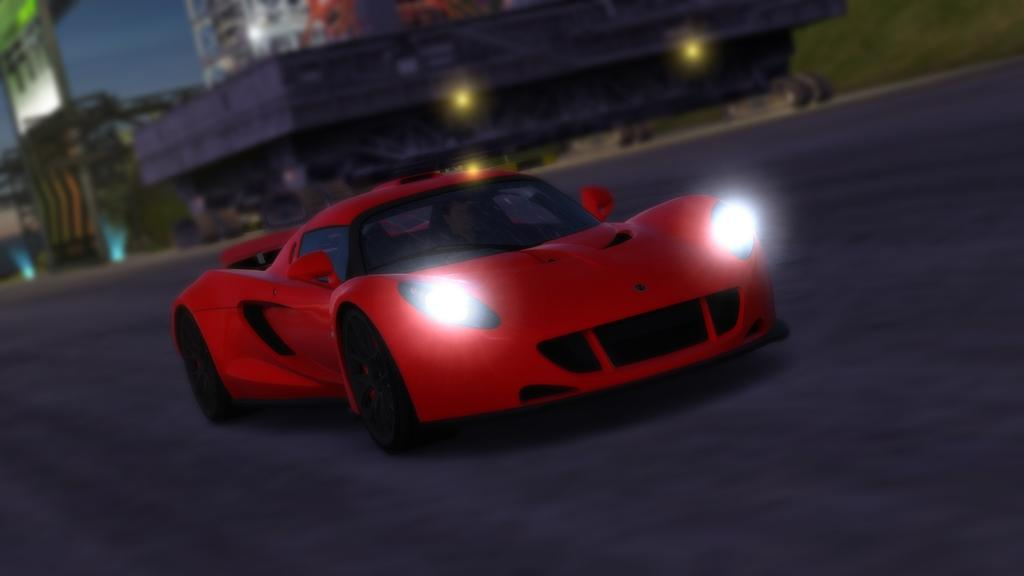What is the main subject of the image? There is a vehicle in the image. Where is the vehicle located? The vehicle is on a roundabout. What can be seen in the background of the image? There are buildings in the background of the image. Where is the playground located in the image? There is no playground present in the image. What type of boot is visible on the vehicle in the image? There is no boot visible on the vehicle in the image. 